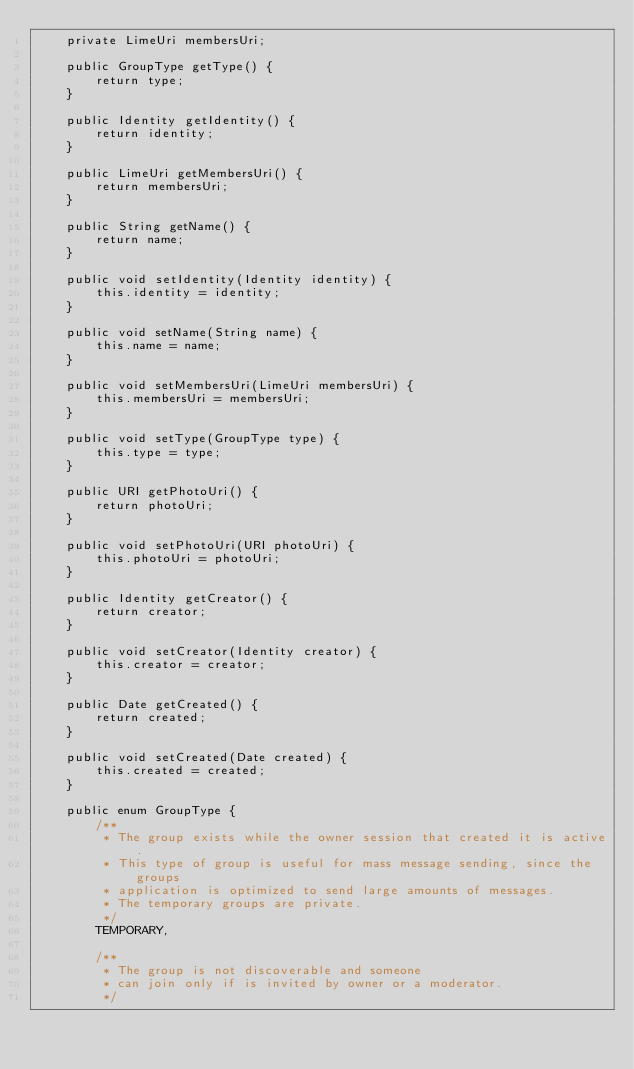<code> <loc_0><loc_0><loc_500><loc_500><_Java_>    private LimeUri membersUri;

    public GroupType getType() {
        return type;
    }

    public Identity getIdentity() {
        return identity;
    }

    public LimeUri getMembersUri() {
        return membersUri;
    }

    public String getName() {
        return name;
    }

    public void setIdentity(Identity identity) {
        this.identity = identity;
    }

    public void setName(String name) {
        this.name = name;
    }

    public void setMembersUri(LimeUri membersUri) {
        this.membersUri = membersUri;
    }

    public void setType(GroupType type) {
        this.type = type;
    }

    public URI getPhotoUri() {
        return photoUri;
    }

    public void setPhotoUri(URI photoUri) {
        this.photoUri = photoUri;
    }

    public Identity getCreator() {
        return creator;
    }

    public void setCreator(Identity creator) {
        this.creator = creator;
    }

    public Date getCreated() {
        return created;
    }

    public void setCreated(Date created) {
        this.created = created;
    }

    public enum GroupType {
        /**
         * The group exists while the owner session that created it is active.
         * This type of group is useful for mass message sending, since the groups
         * application is optimized to send large amounts of messages.
         * The temporary groups are private.
         */
        TEMPORARY,

        /**
         * The group is not discoverable and someone
         * can join only if is invited by owner or a moderator.
         */</code> 